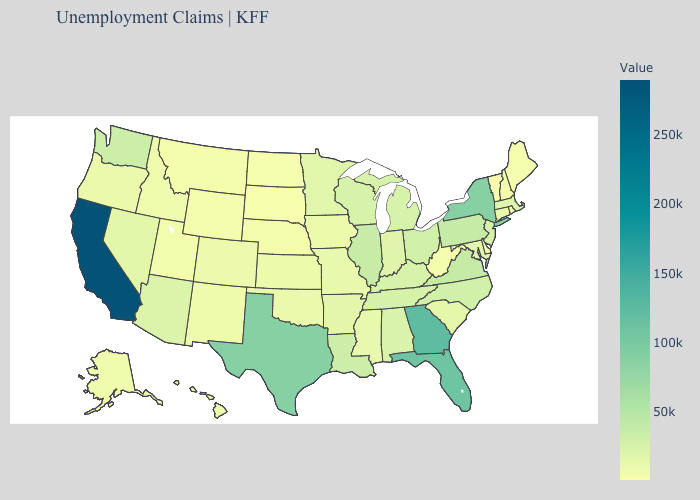Is the legend a continuous bar?
Keep it brief. Yes. Does South Dakota have the lowest value in the USA?
Give a very brief answer. Yes. Among the states that border Oklahoma , which have the highest value?
Concise answer only. Texas. Among the states that border Pennsylvania , does Maryland have the highest value?
Concise answer only. No. 